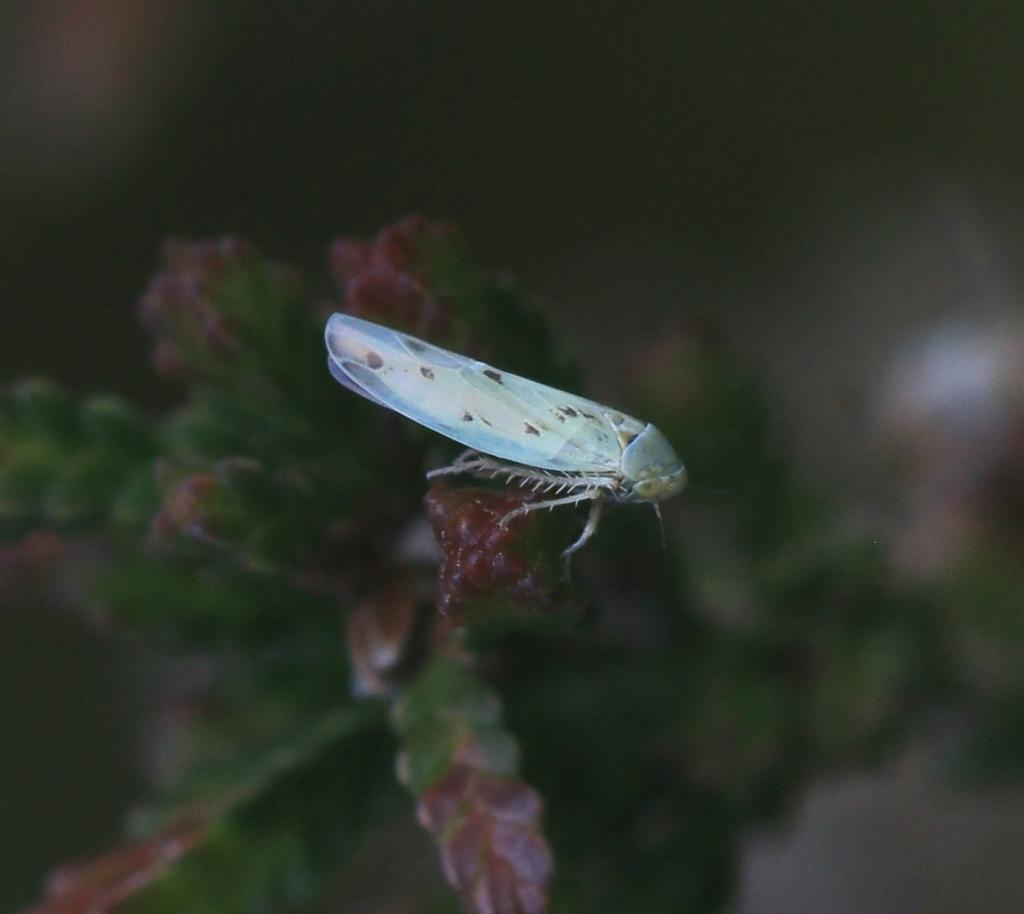What type of creature can be seen in the image? There is an insect in the image. Where is the insect located? The insect is on a plant. What colors are present on the plant? The plant has maroon and green colors. How would you describe the background of the image? The background of the image is blurred. What type of car can be seen in the image? There is no car present in the image; it features an insect on a plant. How does the insect's finger interact with the plant in the image? Insects do not have fingers, so this question is not applicable to the image. 